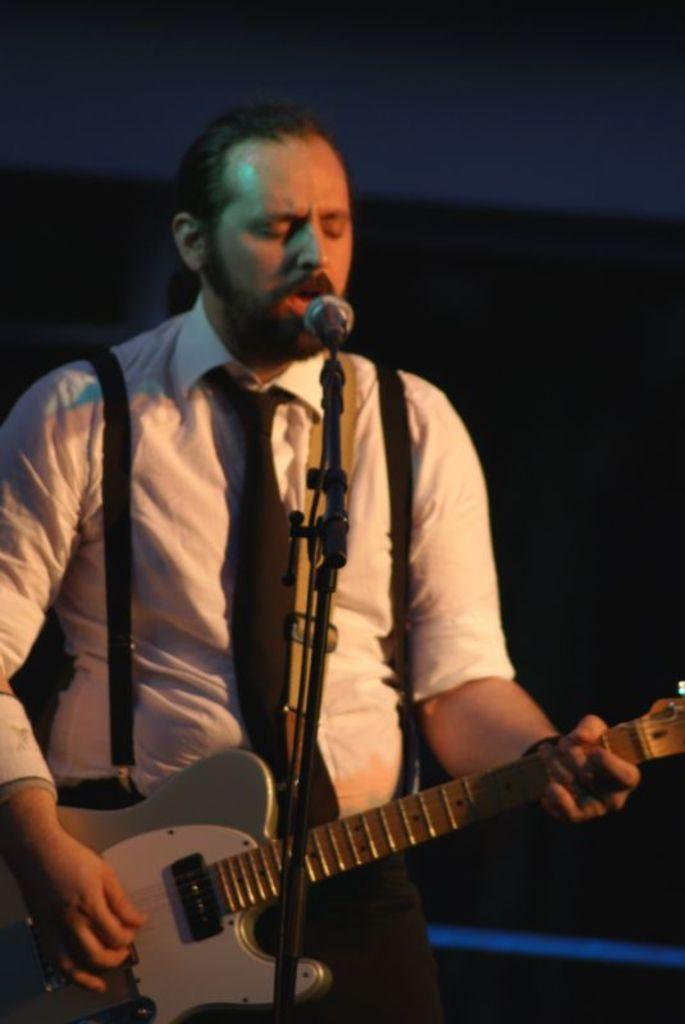What is: What is the man in the image doing? The man is singing in the image. What instrument is the man playing? The man is playing a guitar. What is the man using to amplify his voice? There is a microphone in front of the man. What color is the shirt the man is wearing? The man is wearing a white shirt. What type of accessory is the man wearing around his neck? The man is wearing a tie. What language is the man's grandmother speaking in the image? There is no mention of a grandmother or any language spoken in the image; it only shows a man singing and playing a guitar. 